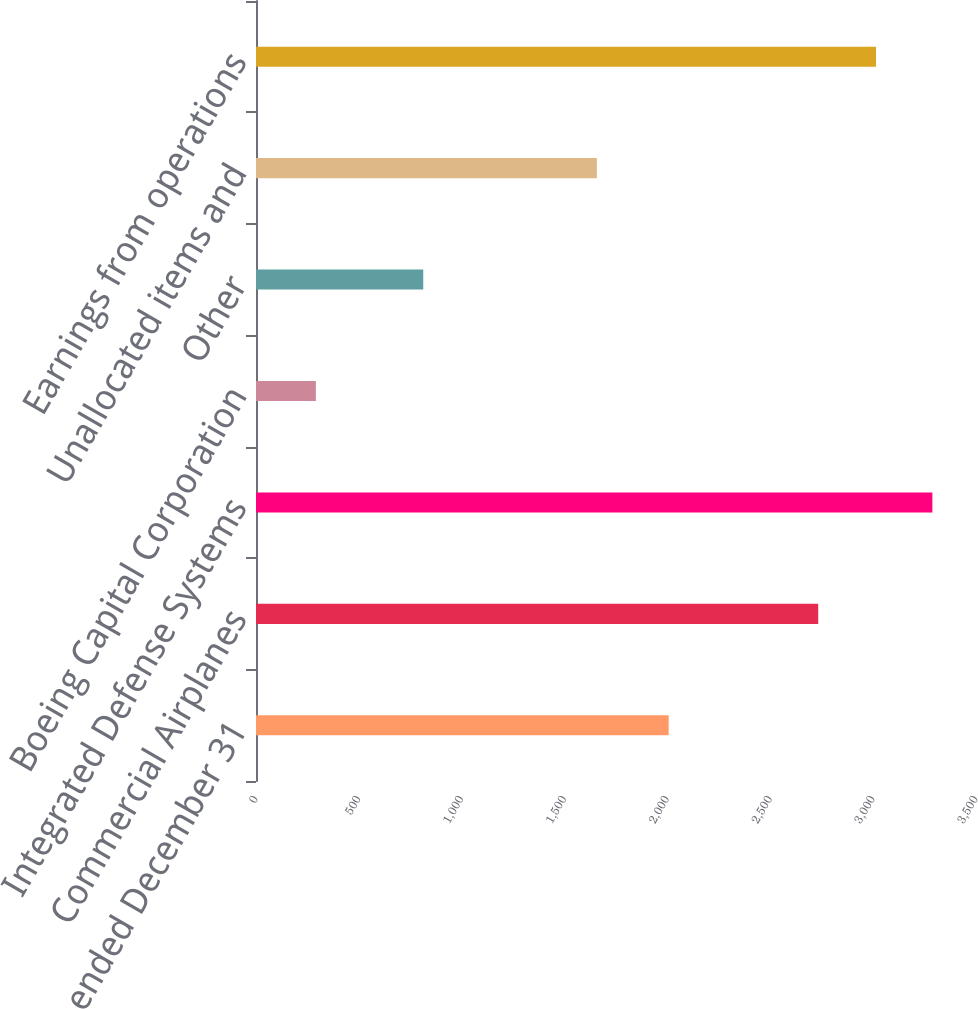Convert chart to OTSL. <chart><loc_0><loc_0><loc_500><loc_500><bar_chart><fcel>Years ended December 31<fcel>Commercial Airplanes<fcel>Integrated Defense Systems<fcel>Boeing Capital Corporation<fcel>Other<fcel>Unallocated items and<fcel>Earnings from operations<nl><fcel>2006<fcel>2733<fcel>3288<fcel>291<fcel>813<fcel>1657<fcel>3014<nl></chart> 